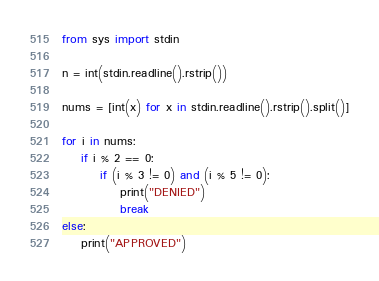Convert code to text. <code><loc_0><loc_0><loc_500><loc_500><_Python_>from sys import stdin

n = int(stdin.readline().rstrip())

nums = [int(x) for x in stdin.readline().rstrip().split()]

for i in nums:
    if i % 2 == 0:
        if (i % 3 != 0) and (i % 5 != 0):
            print("DENIED")
            break
else:
    print("APPROVED")
</code> 